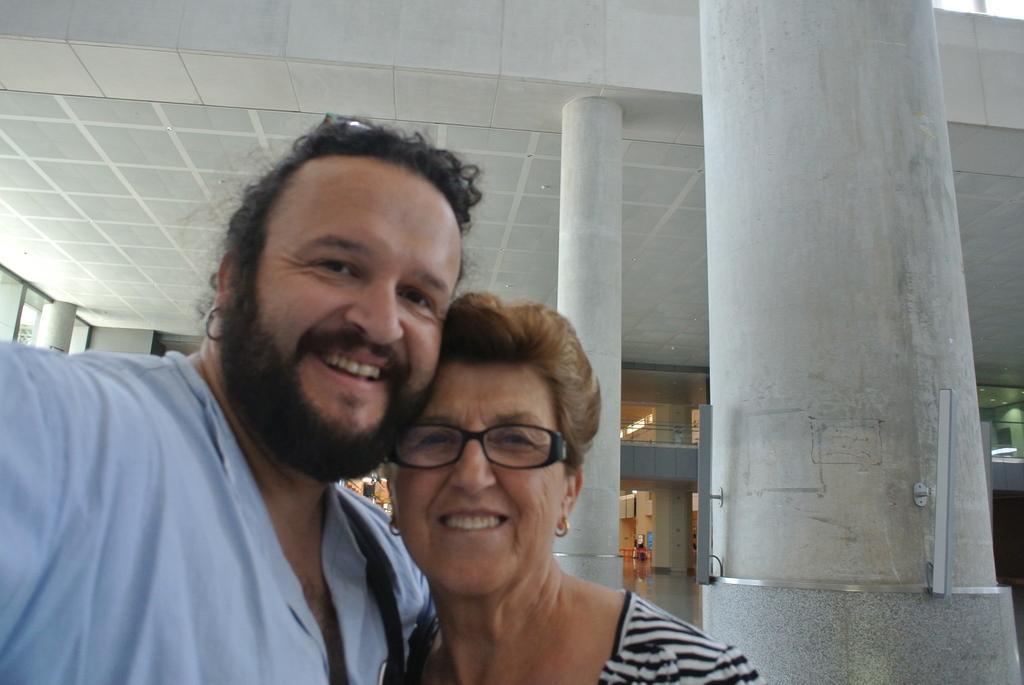Describe this image in one or two sentences. The man in the blue shirt is standing beside the woman who is wearing white and black dress. Both of them are smiling. They are posing for the photo. Behind them, we see pillars and a wall railing. This picture is clicked in the building. At the top of the picture, we see the ceiling of the building. 